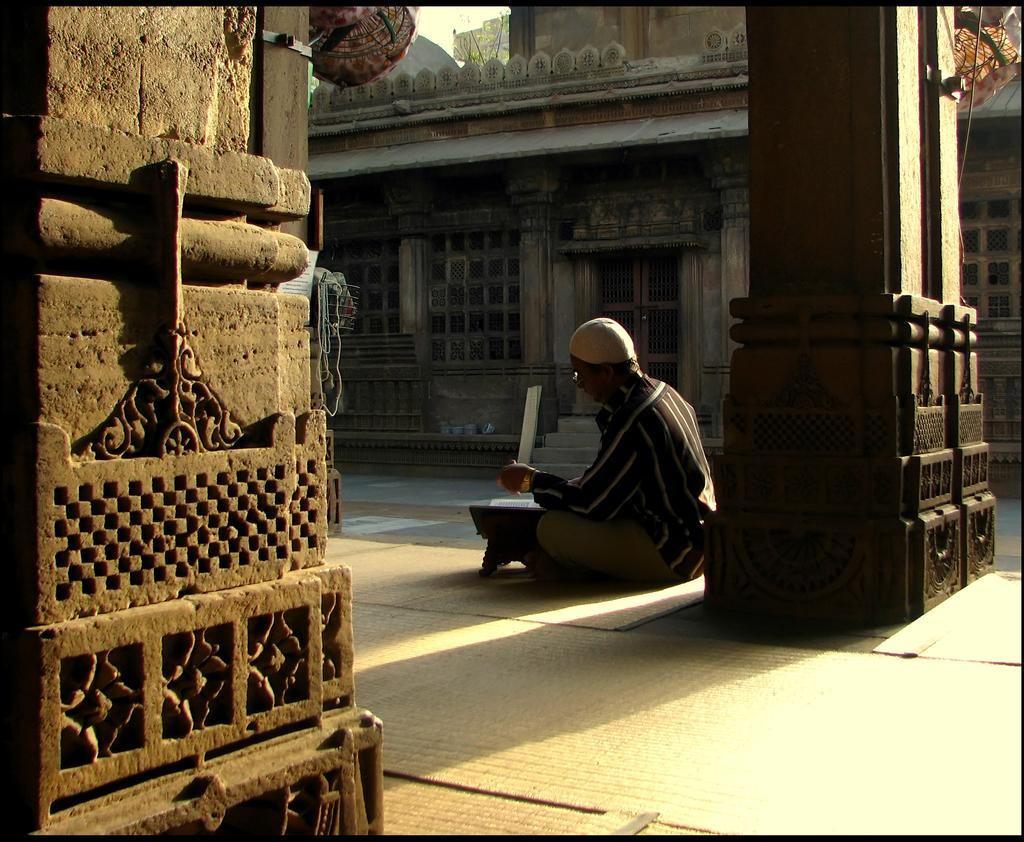What type of structure is visible in the image? There is a house in the image. What architectural feature can be seen near the house? There is a pillar in the image. What is the person in the image doing? There is a person sitting in front of the pillar. What piece of furniture is present in the image? There is a table in the image. What time does the clock show in the image? There is no clock present in the image, so it is not possible to determine the time. 